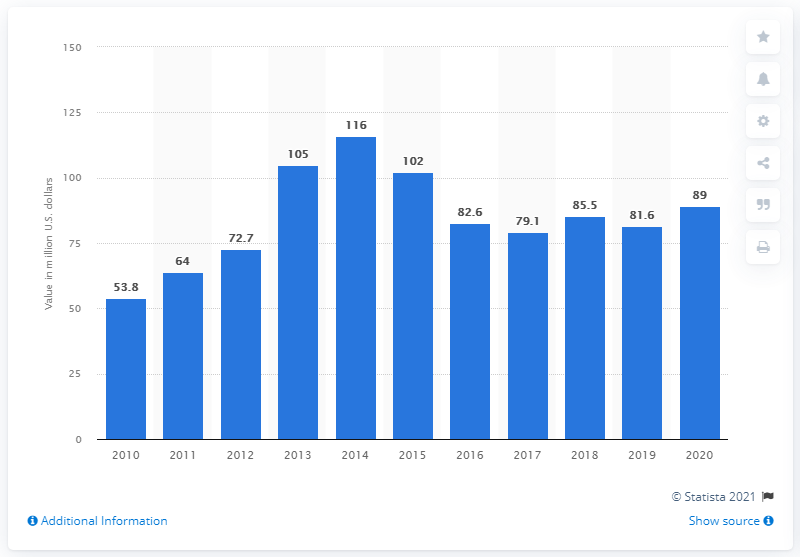Mention a couple of crucial points in this snapshot. In 2020, Brazilian yerba mate exports totaled 89 million dollars. Brazil's yerba mate exports increased by 89% in just one year. 